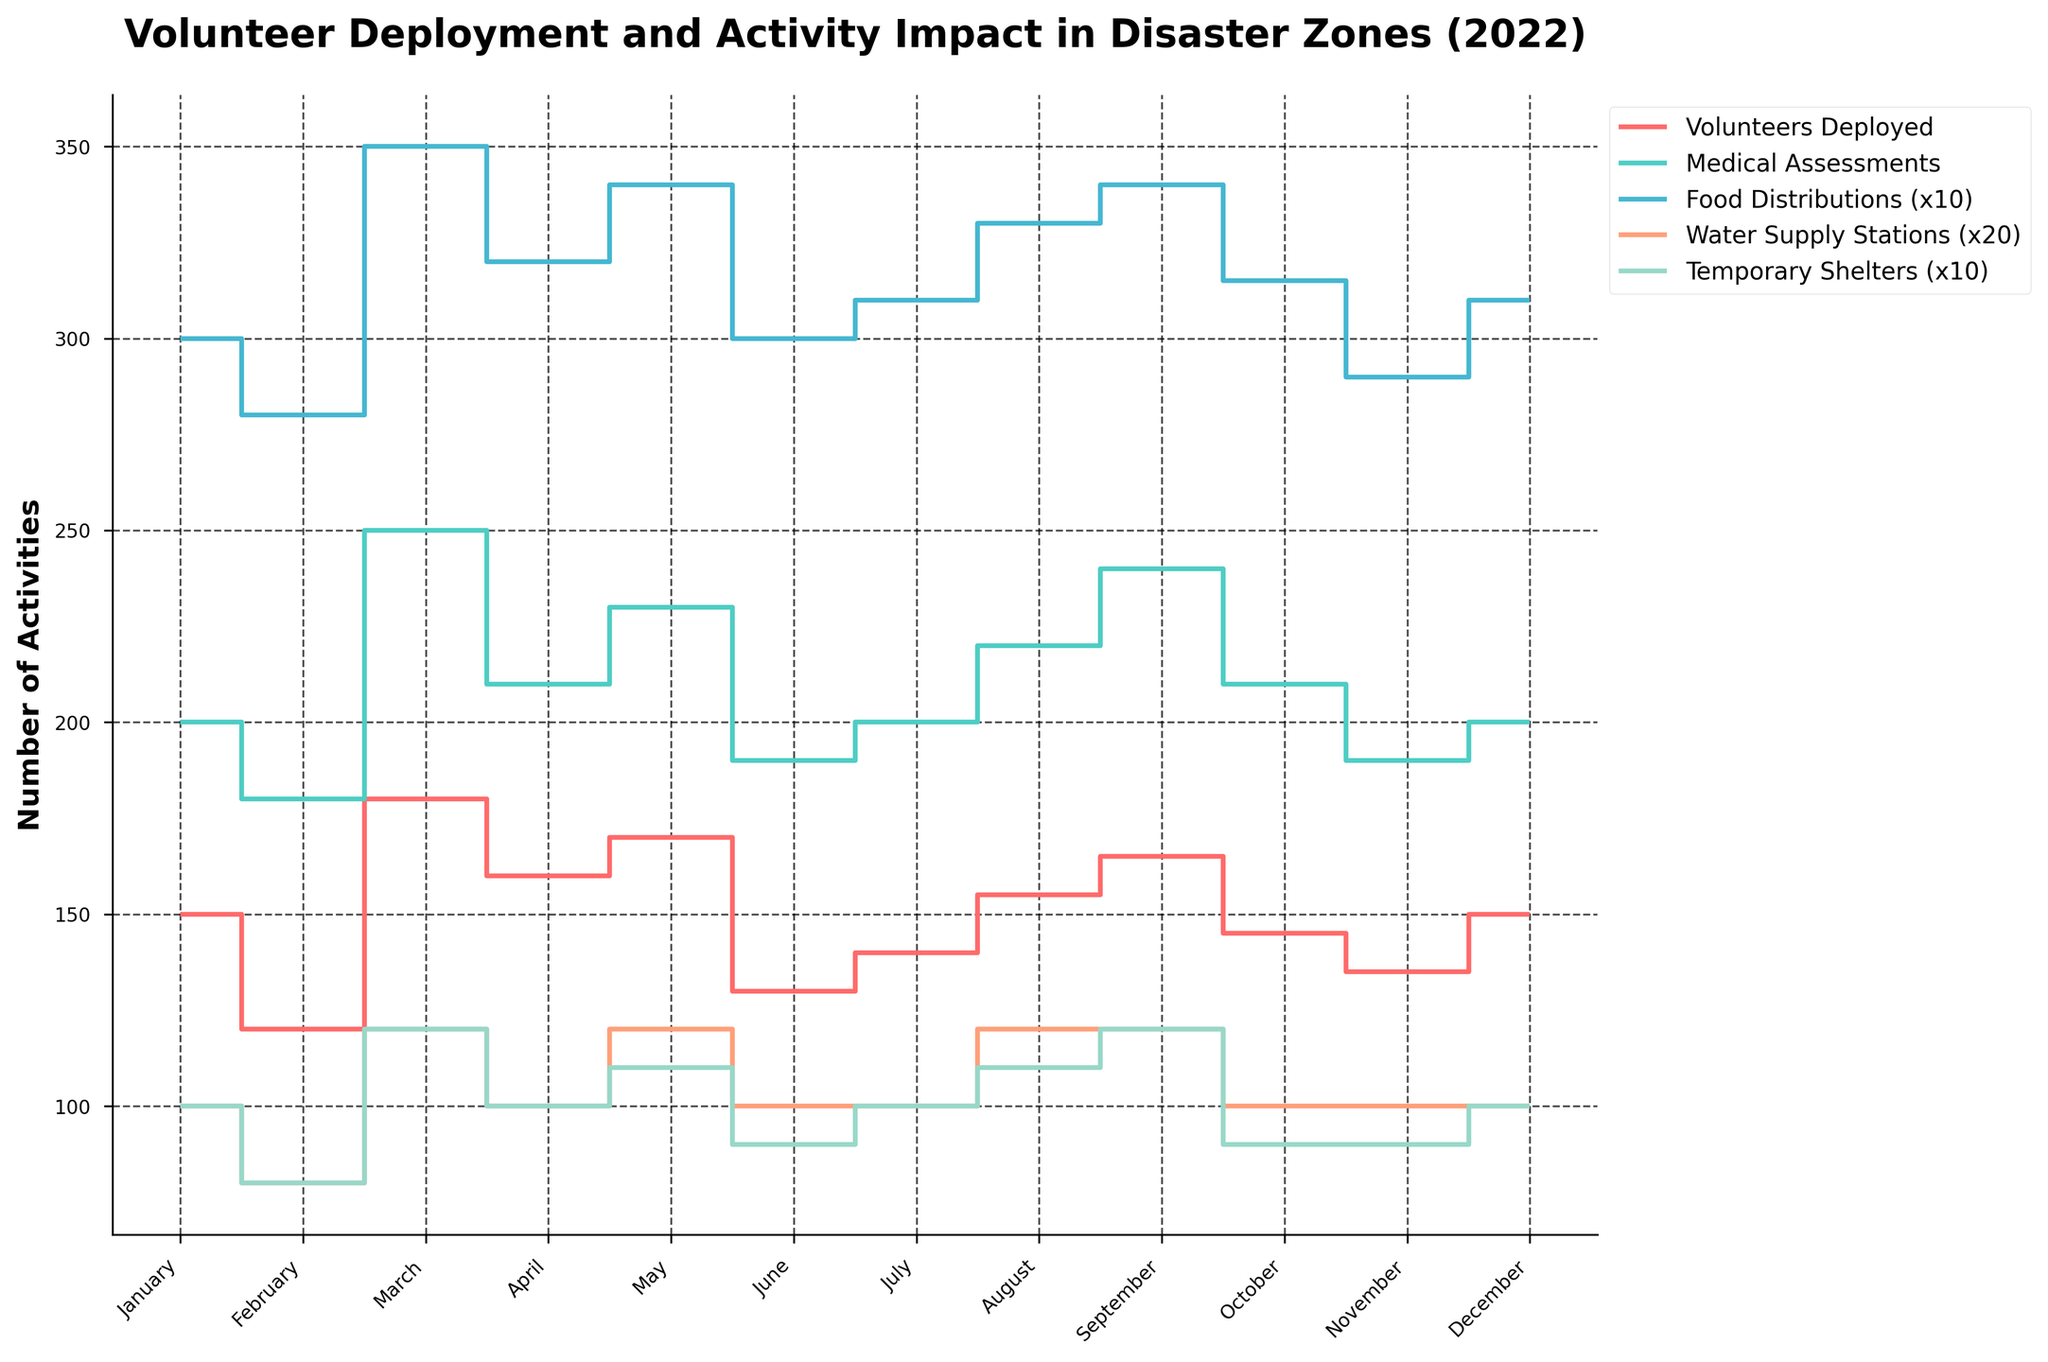How many volunteers were deployed in January 2022? The figure shows the number of volunteers deployed each month. For January 2022, the line at the first x-tick labeled 'January' corresponds to a value of 150.
Answer: 150 During which month was the highest number of medical assessments conducted? By looking at the height of the steps for 'Medical Assessments', the highest peak is in March at 250.
Answer: March Which month had the lowest number of food distributions? The 'Food Distributions (x10)' line is lowest in November. Since the values are divided by 10 for scaling, interpret the lowest peak representing 2900 distributions as November.
Answer: November What is the total number of temporary shelters established from June to August 2022? Sum the number of temporary shelters for June, July, and August: 10 (June) + 10 (July) + 11 (August) = 31. Multiply each by 10, since they are scaled by 10: 31 * 10 = 310.
Answer: 310 By how much did the number of water supply stations increase from February to March 2022? The number of water supply stations in February is 4 and in March is 6. The increase is calculated as 6 - 4, then multiply by 20 due to scaling: (6 - 4) * 20 = 40.
Answer: 40 Which activity had the most significant change from August to September 2022? Compare the step heights between August and September for each activity. 'Medical Assessments' increased from 220 to 240, which is the most noticeable change compared to others.
Answer: Medical Assessments How does the trend of volunteer deployments differ between the first and second halves of 2022? From January to June, volunteer deployments have many fluctuations, 150, 120, 180, 160, 170, 130 respectively. In contrast, from July to December, it varies less drastically: 140, 155, 165, 145, 135, 150. The trend in the first half is more volatile.
Answer: More volatile in the first half What is the average number of medical assessments conducted over the entire year? Add the monthly medical assessments and divide by 12: (200 + 180 + 250 + 210 + 230 + 190 + 200 + 220 + 240 + 210 + 190 + 200) / 12 = 2280 / 12 = 190.
Answer: 190 Between which two adjacent months did the number of food distributions increase the most? Calculate the difference in food distributions for each consecutive month. The greatest increase occurred between February to March (3500 - 2800 = 700), considering the scaling factor of 10: 700 * 10 = 7000.
Answer: February to March Which activity shows the most consistency in numbers across all months? Assess the step patterns for each activity; lines for 'Water Supply Stations (x20)' achieves relative consistency with values like 5, 4, 5, 6, 5, 5, etc., indicating minimal variation month-to-month.
Answer: Water Supply Stations 